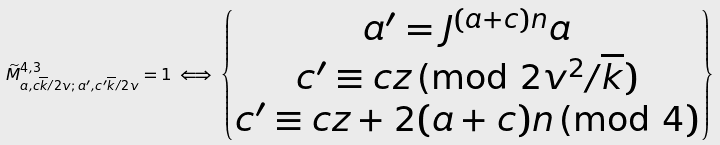Convert formula to latex. <formula><loc_0><loc_0><loc_500><loc_500>\widetilde { M } ^ { 4 , 3 } _ { a , c \overline { k } / 2 v ; \, a ^ { \prime } , c ^ { \prime } \overline { k } / 2 v } = 1 \iff \left \{ \begin{matrix} a ^ { \prime } = J ^ { ( a + c ) n } a \\ c ^ { \prime } \equiv c z \, \text {(mod } 2 v ^ { 2 } / \overline { k } ) \\ c ^ { \prime } \equiv c z + 2 ( a + c ) n \, \text {(mod } 4 ) \\ \end{matrix} \right \}</formula> 